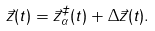Convert formula to latex. <formula><loc_0><loc_0><loc_500><loc_500>\vec { z } ( t ) = \vec { z } _ { \alpha } ^ { \ddag } ( t ) + \Delta \vec { z } ( t ) .</formula> 